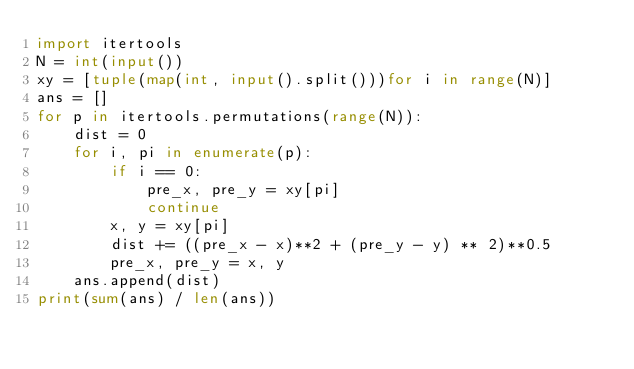Convert code to text. <code><loc_0><loc_0><loc_500><loc_500><_Python_>import itertools
N = int(input())
xy = [tuple(map(int, input().split()))for i in range(N)]
ans = []
for p in itertools.permutations(range(N)):
    dist = 0
    for i, pi in enumerate(p):
        if i == 0:
            pre_x, pre_y = xy[pi]
            continue
        x, y = xy[pi]
        dist += ((pre_x - x)**2 + (pre_y - y) ** 2)**0.5
        pre_x, pre_y = x, y
    ans.append(dist)
print(sum(ans) / len(ans))</code> 